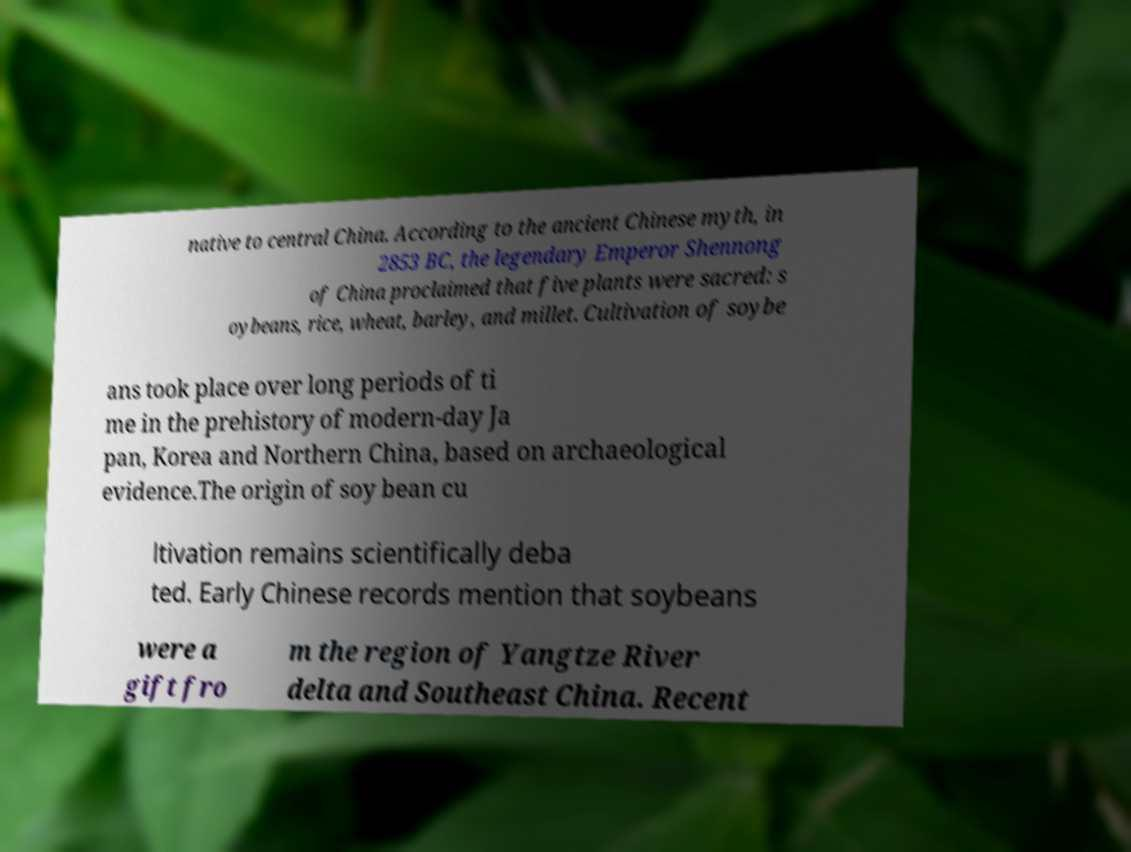Please identify and transcribe the text found in this image. native to central China. According to the ancient Chinese myth, in 2853 BC, the legendary Emperor Shennong of China proclaimed that five plants were sacred: s oybeans, rice, wheat, barley, and millet. Cultivation of soybe ans took place over long periods of ti me in the prehistory of modern-day Ja pan, Korea and Northern China, based on archaeological evidence.The origin of soy bean cu ltivation remains scientifically deba ted. Early Chinese records mention that soybeans were a gift fro m the region of Yangtze River delta and Southeast China. Recent 